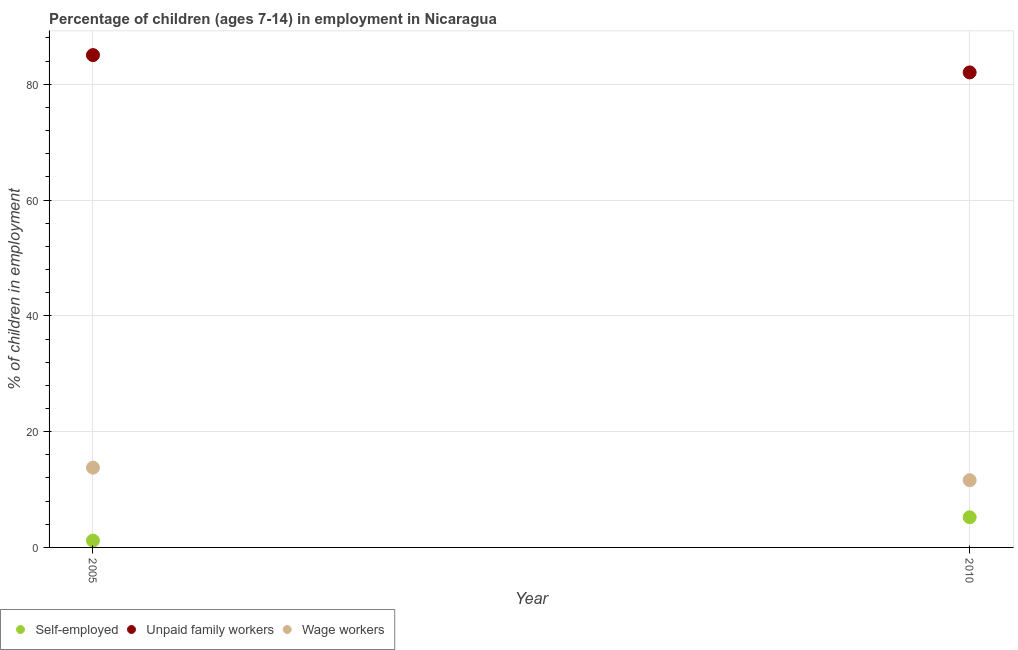How many different coloured dotlines are there?
Ensure brevity in your answer.  3. Is the number of dotlines equal to the number of legend labels?
Provide a short and direct response. Yes. What is the percentage of children employed as unpaid family workers in 2005?
Provide a short and direct response. 85.04. Across all years, what is the maximum percentage of self employed children?
Your answer should be very brief. 5.21. Across all years, what is the minimum percentage of self employed children?
Provide a short and direct response. 1.18. In which year was the percentage of children employed as unpaid family workers maximum?
Provide a succinct answer. 2005. What is the total percentage of children employed as unpaid family workers in the graph?
Offer a terse response. 167.09. What is the difference between the percentage of children employed as unpaid family workers in 2005 and that in 2010?
Ensure brevity in your answer.  2.99. What is the difference between the percentage of children employed as wage workers in 2010 and the percentage of children employed as unpaid family workers in 2005?
Your answer should be compact. -73.43. What is the average percentage of children employed as wage workers per year?
Make the answer very short. 12.7. In the year 2010, what is the difference between the percentage of children employed as unpaid family workers and percentage of self employed children?
Keep it short and to the point. 76.84. In how many years, is the percentage of children employed as unpaid family workers greater than 32 %?
Offer a very short reply. 2. What is the ratio of the percentage of children employed as unpaid family workers in 2005 to that in 2010?
Offer a terse response. 1.04. Is the percentage of self employed children in 2005 less than that in 2010?
Make the answer very short. Yes. In how many years, is the percentage of children employed as unpaid family workers greater than the average percentage of children employed as unpaid family workers taken over all years?
Give a very brief answer. 1. Is it the case that in every year, the sum of the percentage of self employed children and percentage of children employed as unpaid family workers is greater than the percentage of children employed as wage workers?
Make the answer very short. Yes. Does the percentage of self employed children monotonically increase over the years?
Make the answer very short. Yes. Is the percentage of children employed as wage workers strictly greater than the percentage of self employed children over the years?
Ensure brevity in your answer.  Yes. What is the difference between two consecutive major ticks on the Y-axis?
Offer a terse response. 20. Does the graph contain any zero values?
Your answer should be very brief. No. Where does the legend appear in the graph?
Keep it short and to the point. Bottom left. How many legend labels are there?
Give a very brief answer. 3. What is the title of the graph?
Your answer should be very brief. Percentage of children (ages 7-14) in employment in Nicaragua. What is the label or title of the Y-axis?
Make the answer very short. % of children in employment. What is the % of children in employment in Self-employed in 2005?
Offer a terse response. 1.18. What is the % of children in employment of Unpaid family workers in 2005?
Ensure brevity in your answer.  85.04. What is the % of children in employment in Wage workers in 2005?
Give a very brief answer. 13.78. What is the % of children in employment in Self-employed in 2010?
Keep it short and to the point. 5.21. What is the % of children in employment in Unpaid family workers in 2010?
Your answer should be compact. 82.05. What is the % of children in employment of Wage workers in 2010?
Offer a terse response. 11.61. Across all years, what is the maximum % of children in employment in Self-employed?
Ensure brevity in your answer.  5.21. Across all years, what is the maximum % of children in employment in Unpaid family workers?
Your response must be concise. 85.04. Across all years, what is the maximum % of children in employment in Wage workers?
Your response must be concise. 13.78. Across all years, what is the minimum % of children in employment of Self-employed?
Your answer should be very brief. 1.18. Across all years, what is the minimum % of children in employment in Unpaid family workers?
Your answer should be compact. 82.05. Across all years, what is the minimum % of children in employment of Wage workers?
Your answer should be compact. 11.61. What is the total % of children in employment in Self-employed in the graph?
Provide a succinct answer. 6.39. What is the total % of children in employment of Unpaid family workers in the graph?
Provide a short and direct response. 167.09. What is the total % of children in employment in Wage workers in the graph?
Provide a short and direct response. 25.39. What is the difference between the % of children in employment of Self-employed in 2005 and that in 2010?
Your answer should be very brief. -4.03. What is the difference between the % of children in employment in Unpaid family workers in 2005 and that in 2010?
Give a very brief answer. 2.99. What is the difference between the % of children in employment in Wage workers in 2005 and that in 2010?
Offer a terse response. 2.17. What is the difference between the % of children in employment of Self-employed in 2005 and the % of children in employment of Unpaid family workers in 2010?
Your response must be concise. -80.87. What is the difference between the % of children in employment in Self-employed in 2005 and the % of children in employment in Wage workers in 2010?
Your response must be concise. -10.43. What is the difference between the % of children in employment in Unpaid family workers in 2005 and the % of children in employment in Wage workers in 2010?
Your response must be concise. 73.43. What is the average % of children in employment of Self-employed per year?
Give a very brief answer. 3.19. What is the average % of children in employment of Unpaid family workers per year?
Provide a short and direct response. 83.55. What is the average % of children in employment of Wage workers per year?
Keep it short and to the point. 12.7. In the year 2005, what is the difference between the % of children in employment in Self-employed and % of children in employment in Unpaid family workers?
Provide a succinct answer. -83.86. In the year 2005, what is the difference between the % of children in employment in Unpaid family workers and % of children in employment in Wage workers?
Keep it short and to the point. 71.26. In the year 2010, what is the difference between the % of children in employment of Self-employed and % of children in employment of Unpaid family workers?
Provide a short and direct response. -76.84. In the year 2010, what is the difference between the % of children in employment of Self-employed and % of children in employment of Wage workers?
Give a very brief answer. -6.4. In the year 2010, what is the difference between the % of children in employment in Unpaid family workers and % of children in employment in Wage workers?
Provide a succinct answer. 70.44. What is the ratio of the % of children in employment of Self-employed in 2005 to that in 2010?
Provide a short and direct response. 0.23. What is the ratio of the % of children in employment of Unpaid family workers in 2005 to that in 2010?
Ensure brevity in your answer.  1.04. What is the ratio of the % of children in employment of Wage workers in 2005 to that in 2010?
Your answer should be compact. 1.19. What is the difference between the highest and the second highest % of children in employment of Self-employed?
Provide a succinct answer. 4.03. What is the difference between the highest and the second highest % of children in employment of Unpaid family workers?
Offer a terse response. 2.99. What is the difference between the highest and the second highest % of children in employment in Wage workers?
Give a very brief answer. 2.17. What is the difference between the highest and the lowest % of children in employment of Self-employed?
Your answer should be compact. 4.03. What is the difference between the highest and the lowest % of children in employment in Unpaid family workers?
Offer a very short reply. 2.99. What is the difference between the highest and the lowest % of children in employment of Wage workers?
Offer a terse response. 2.17. 